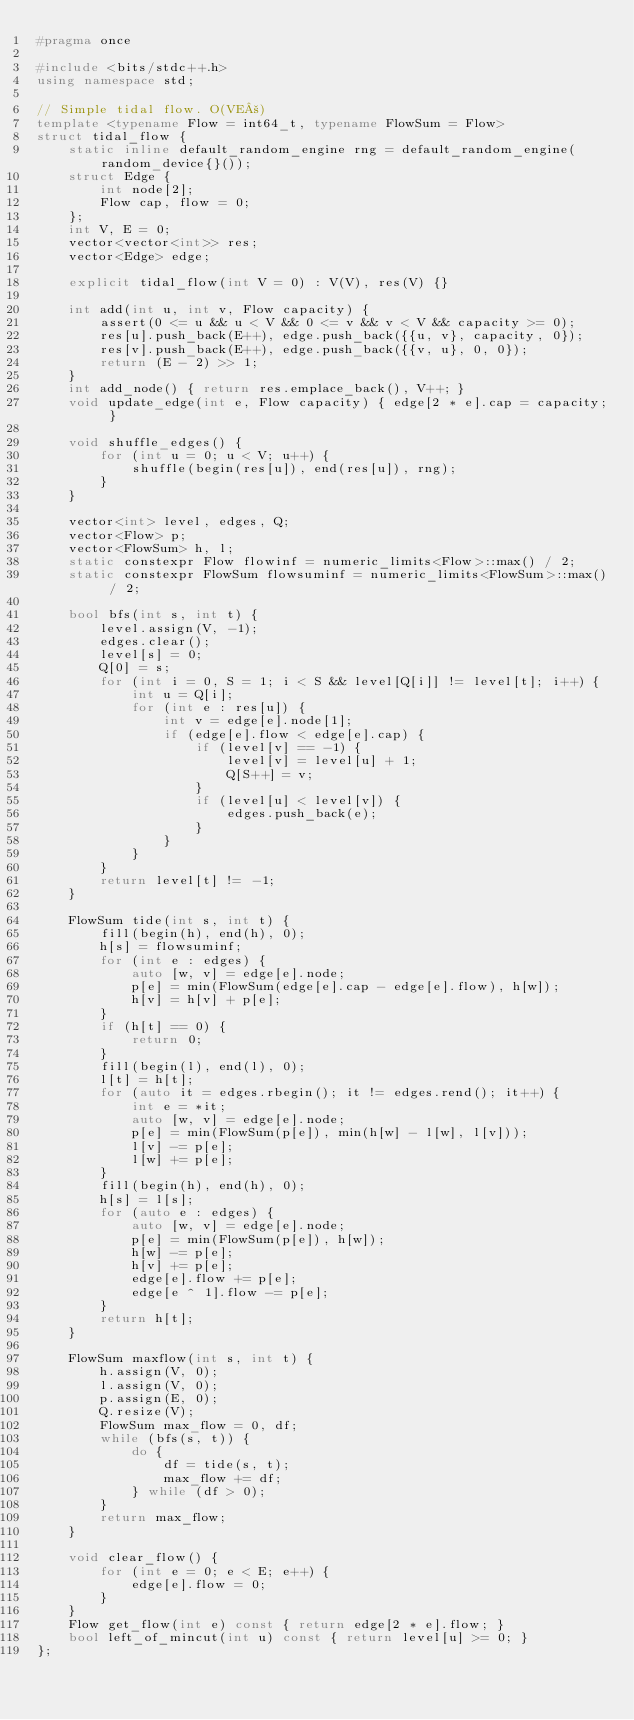Convert code to text. <code><loc_0><loc_0><loc_500><loc_500><_C++_>#pragma once

#include <bits/stdc++.h>
using namespace std;

// Simple tidal flow. O(VE²)
template <typename Flow = int64_t, typename FlowSum = Flow>
struct tidal_flow {
    static inline default_random_engine rng = default_random_engine(random_device{}());
    struct Edge {
        int node[2];
        Flow cap, flow = 0;
    };
    int V, E = 0;
    vector<vector<int>> res;
    vector<Edge> edge;

    explicit tidal_flow(int V = 0) : V(V), res(V) {}

    int add(int u, int v, Flow capacity) {
        assert(0 <= u && u < V && 0 <= v && v < V && capacity >= 0);
        res[u].push_back(E++), edge.push_back({{u, v}, capacity, 0});
        res[v].push_back(E++), edge.push_back({{v, u}, 0, 0});
        return (E - 2) >> 1;
    }
    int add_node() { return res.emplace_back(), V++; }
    void update_edge(int e, Flow capacity) { edge[2 * e].cap = capacity; }

    void shuffle_edges() {
        for (int u = 0; u < V; u++) {
            shuffle(begin(res[u]), end(res[u]), rng);
        }
    }

    vector<int> level, edges, Q;
    vector<Flow> p;
    vector<FlowSum> h, l;
    static constexpr Flow flowinf = numeric_limits<Flow>::max() / 2;
    static constexpr FlowSum flowsuminf = numeric_limits<FlowSum>::max() / 2;

    bool bfs(int s, int t) {
        level.assign(V, -1);
        edges.clear();
        level[s] = 0;
        Q[0] = s;
        for (int i = 0, S = 1; i < S && level[Q[i]] != level[t]; i++) {
            int u = Q[i];
            for (int e : res[u]) {
                int v = edge[e].node[1];
                if (edge[e].flow < edge[e].cap) {
                    if (level[v] == -1) {
                        level[v] = level[u] + 1;
                        Q[S++] = v;
                    }
                    if (level[u] < level[v]) {
                        edges.push_back(e);
                    }
                }
            }
        }
        return level[t] != -1;
    }

    FlowSum tide(int s, int t) {
        fill(begin(h), end(h), 0);
        h[s] = flowsuminf;
        for (int e : edges) {
            auto [w, v] = edge[e].node;
            p[e] = min(FlowSum(edge[e].cap - edge[e].flow), h[w]);
            h[v] = h[v] + p[e];
        }
        if (h[t] == 0) {
            return 0;
        }
        fill(begin(l), end(l), 0);
        l[t] = h[t];
        for (auto it = edges.rbegin(); it != edges.rend(); it++) {
            int e = *it;
            auto [w, v] = edge[e].node;
            p[e] = min(FlowSum(p[e]), min(h[w] - l[w], l[v]));
            l[v] -= p[e];
            l[w] += p[e];
        }
        fill(begin(h), end(h), 0);
        h[s] = l[s];
        for (auto e : edges) {
            auto [w, v] = edge[e].node;
            p[e] = min(FlowSum(p[e]), h[w]);
            h[w] -= p[e];
            h[v] += p[e];
            edge[e].flow += p[e];
            edge[e ^ 1].flow -= p[e];
        }
        return h[t];
    }

    FlowSum maxflow(int s, int t) {
        h.assign(V, 0);
        l.assign(V, 0);
        p.assign(E, 0);
        Q.resize(V);
        FlowSum max_flow = 0, df;
        while (bfs(s, t)) {
            do {
                df = tide(s, t);
                max_flow += df;
            } while (df > 0);
        }
        return max_flow;
    }

    void clear_flow() {
        for (int e = 0; e < E; e++) {
            edge[e].flow = 0;
        }
    }
    Flow get_flow(int e) const { return edge[2 * e].flow; }
    bool left_of_mincut(int u) const { return level[u] >= 0; }
};
</code> 